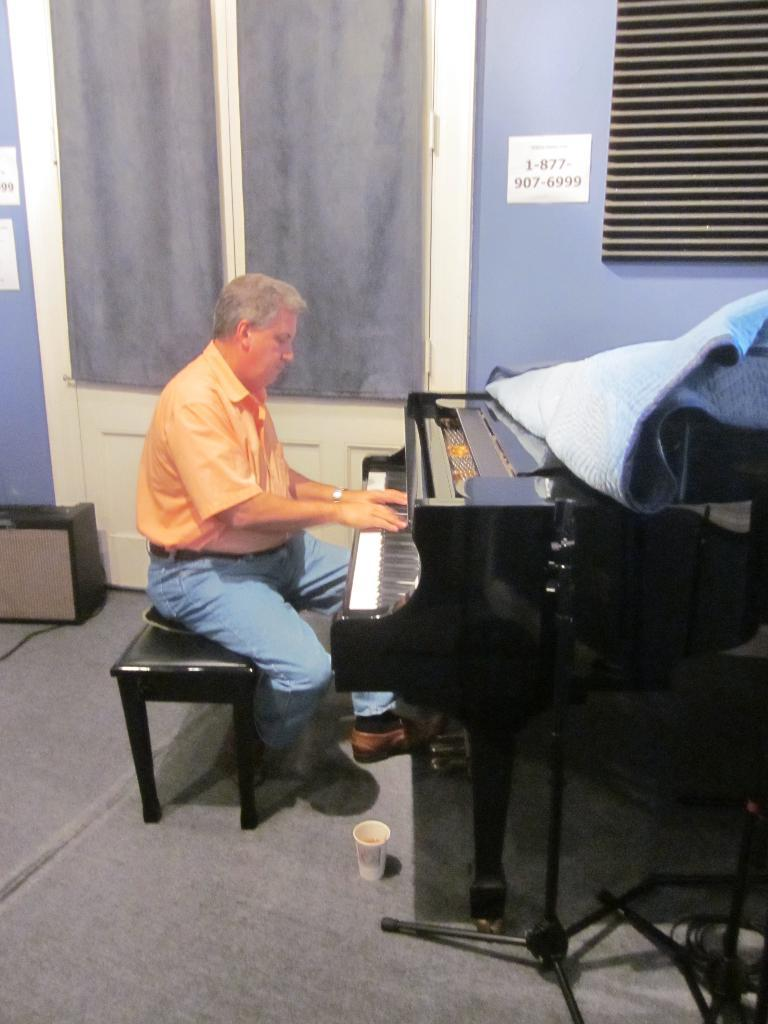Who or what is the main subject in the image? There is a person in the image. What is the person doing in the image? The person is playing a piano. What is the person sitting on while playing the piano? The person is sitting on a chair. What type of cork can be seen on the ground in the image? There is no cork present on the ground in the image. 